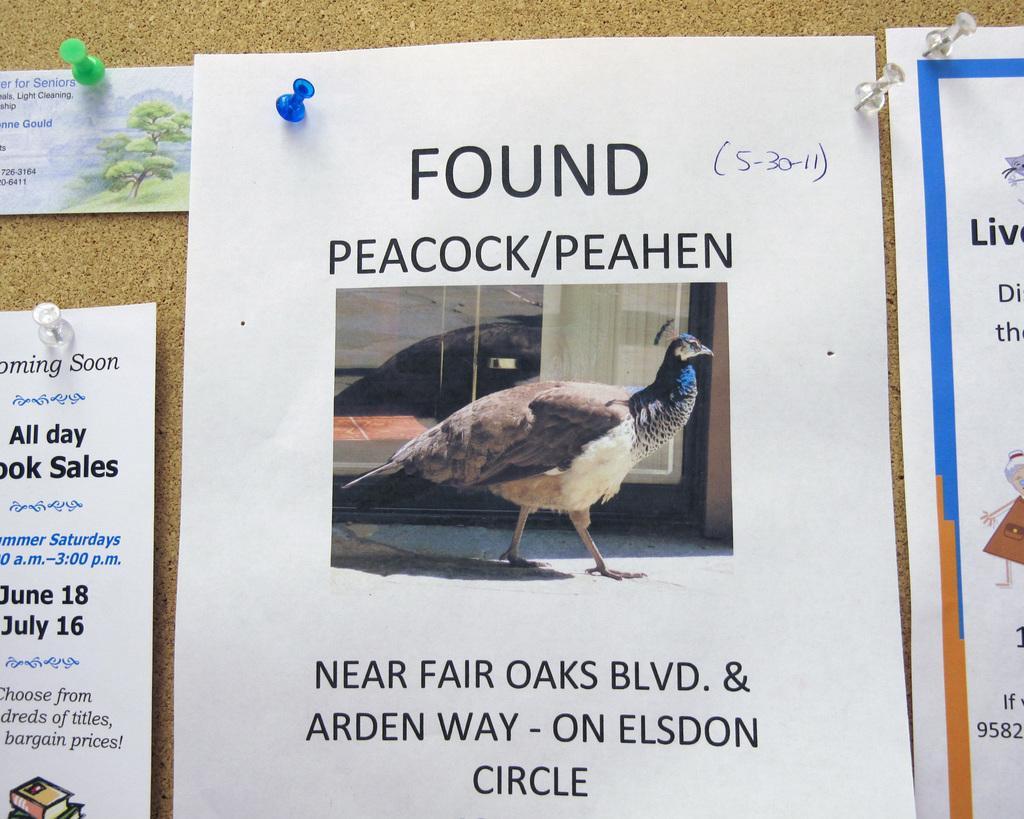Please provide a concise description of this image. In this image there are a few papers with some images and text are attached to a wall. 